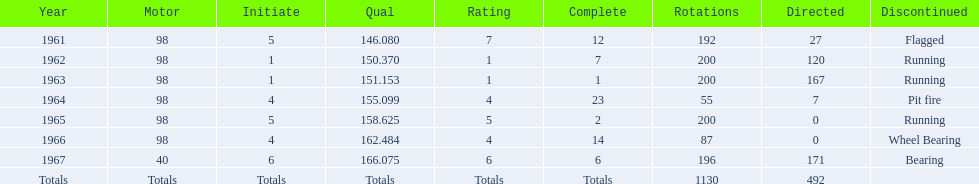I'm looking to parse the entire table for insights. Could you assist me with that? {'header': ['Year', 'Motor', 'Initiate', 'Qual', 'Rating', 'Complete', 'Rotations', 'Directed', 'Discontinued'], 'rows': [['1961', '98', '5', '146.080', '7', '12', '192', '27', 'Flagged'], ['1962', '98', '1', '150.370', '1', '7', '200', '120', 'Running'], ['1963', '98', '1', '151.153', '1', '1', '200', '167', 'Running'], ['1964', '98', '4', '155.099', '4', '23', '55', '7', 'Pit fire'], ['1965', '98', '5', '158.625', '5', '2', '200', '0', 'Running'], ['1966', '98', '4', '162.484', '4', '14', '87', '0', 'Wheel Bearing'], ['1967', '40', '6', '166.075', '6', '6', '196', '171', 'Bearing'], ['Totals', 'Totals', 'Totals', 'Totals', 'Totals', 'Totals', '1130', '492', '']]} How many consecutive years did parnelli place in the top 5? 5. 